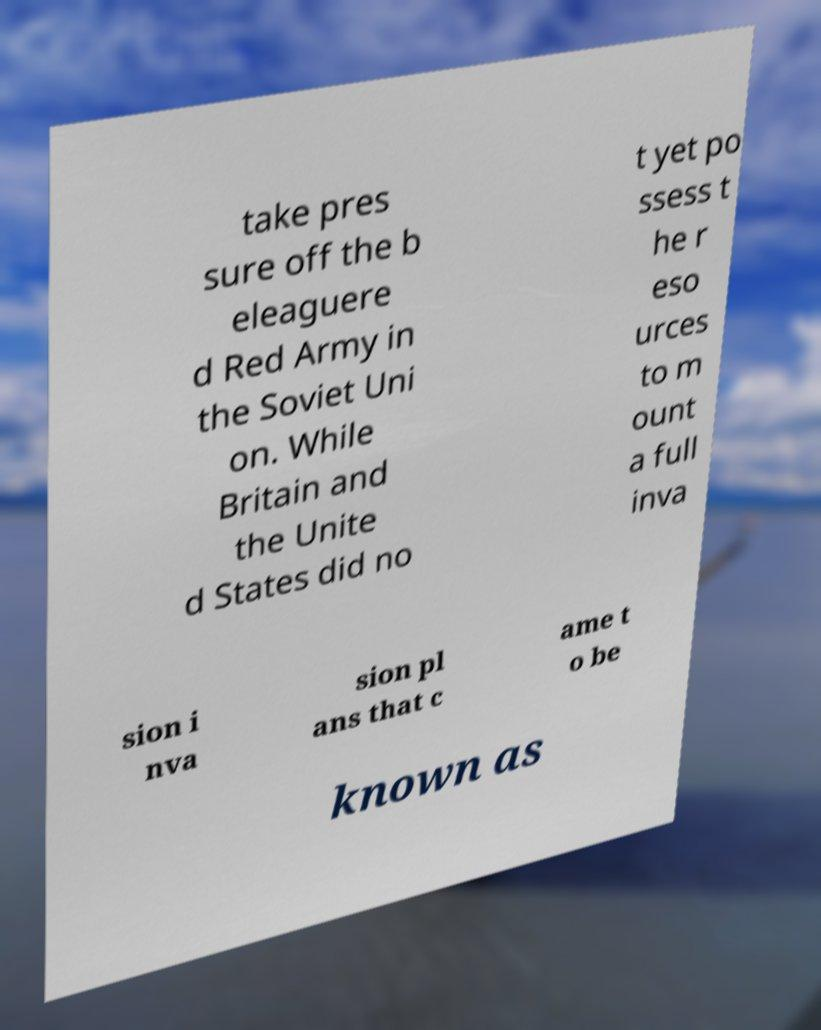There's text embedded in this image that I need extracted. Can you transcribe it verbatim? take pres sure off the b eleaguere d Red Army in the Soviet Uni on. While Britain and the Unite d States did no t yet po ssess t he r eso urces to m ount a full inva sion i nva sion pl ans that c ame t o be known as 